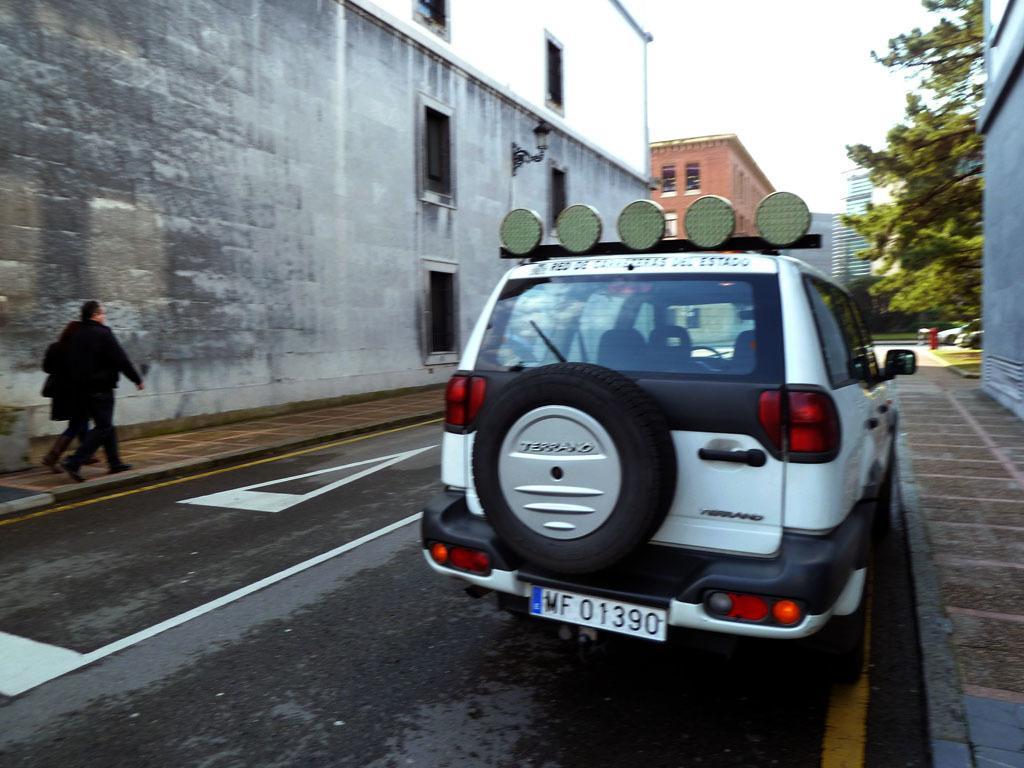Please provide a concise description of this image. In this image there are vehicles on the road. On the left side of the image there are two people walking on the pavement. In the background of the image there are buildings, trees, lamp posts. At the top of the image there is sky. 